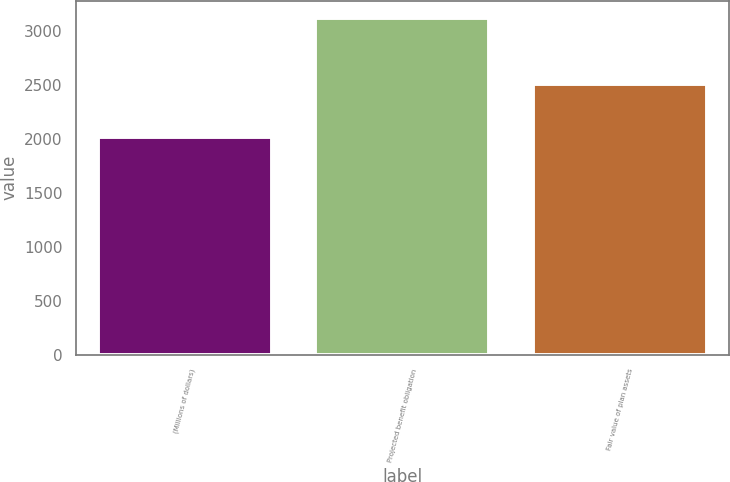Convert chart to OTSL. <chart><loc_0><loc_0><loc_500><loc_500><bar_chart><fcel>(Millions of dollars)<fcel>Projected benefit obligation<fcel>Fair value of plan assets<nl><fcel>2018<fcel>3121<fcel>2502<nl></chart> 